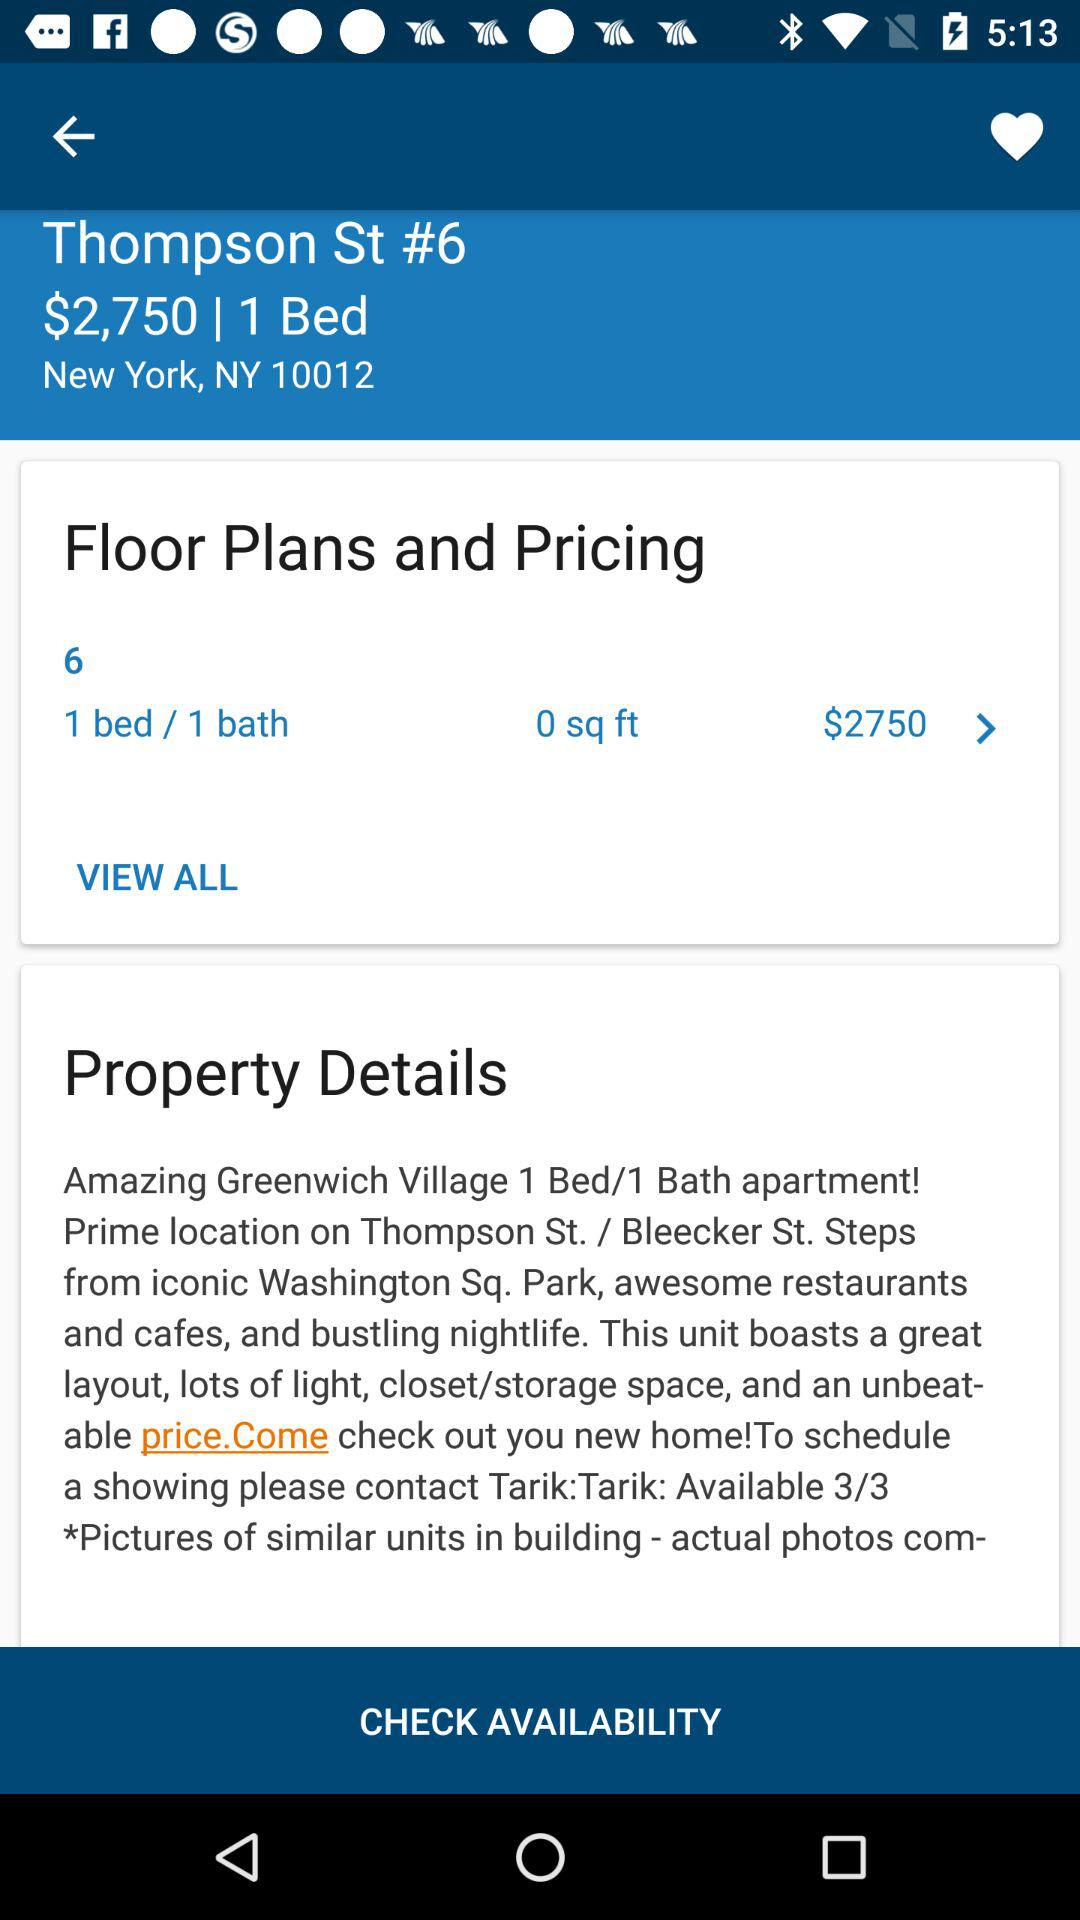How many bedrooms does this apartment have?
Answer the question using a single word or phrase. 1 